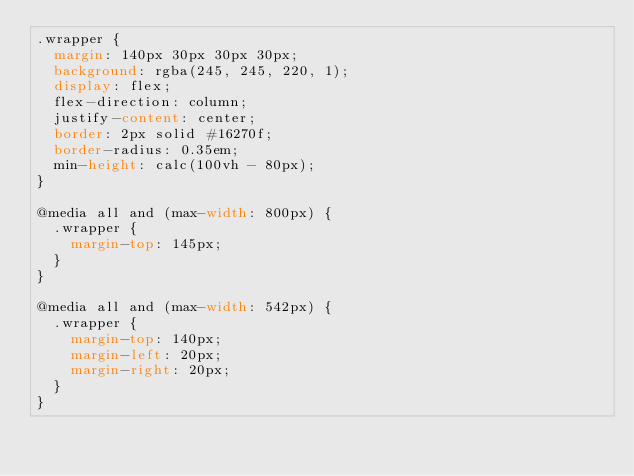Convert code to text. <code><loc_0><loc_0><loc_500><loc_500><_CSS_>.wrapper {
  margin: 140px 30px 30px 30px;
  background: rgba(245, 245, 220, 1);
  display: flex;
  flex-direction: column;
  justify-content: center;
  border: 2px solid #16270f;
  border-radius: 0.35em;
  min-height: calc(100vh - 80px);
}

@media all and (max-width: 800px) {
  .wrapper {
    margin-top: 145px;
  }
}

@media all and (max-width: 542px) {
  .wrapper {
    margin-top: 140px;
    margin-left: 20px;
    margin-right: 20px;
  }
}
</code> 